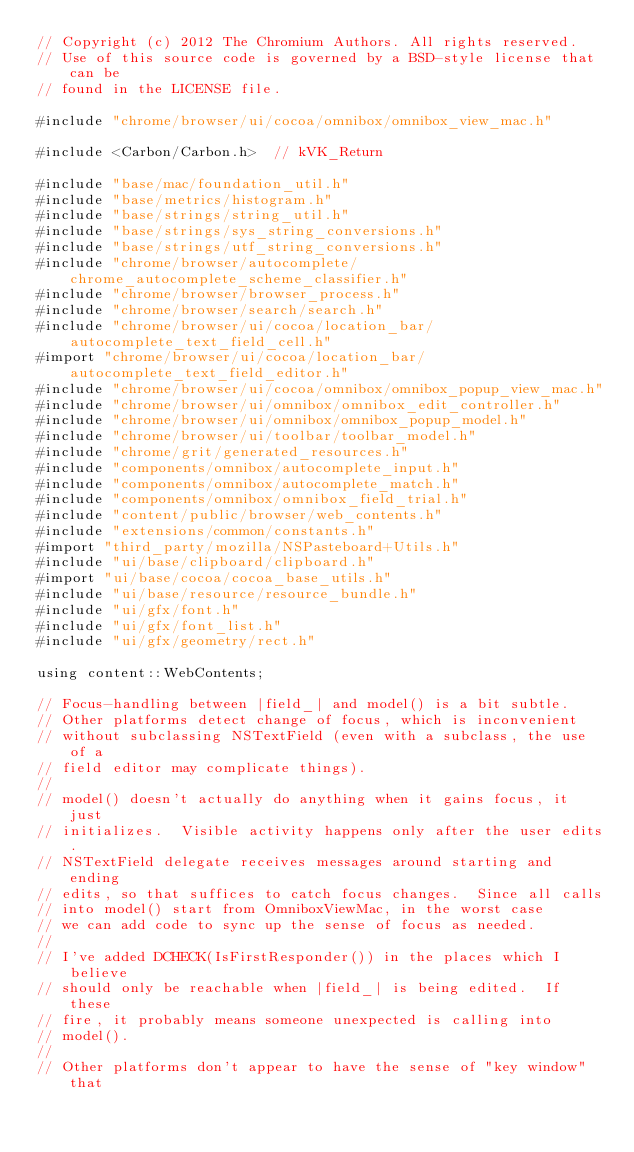<code> <loc_0><loc_0><loc_500><loc_500><_ObjectiveC_>// Copyright (c) 2012 The Chromium Authors. All rights reserved.
// Use of this source code is governed by a BSD-style license that can be
// found in the LICENSE file.

#include "chrome/browser/ui/cocoa/omnibox/omnibox_view_mac.h"

#include <Carbon/Carbon.h>  // kVK_Return

#include "base/mac/foundation_util.h"
#include "base/metrics/histogram.h"
#include "base/strings/string_util.h"
#include "base/strings/sys_string_conversions.h"
#include "base/strings/utf_string_conversions.h"
#include "chrome/browser/autocomplete/chrome_autocomplete_scheme_classifier.h"
#include "chrome/browser/browser_process.h"
#include "chrome/browser/search/search.h"
#include "chrome/browser/ui/cocoa/location_bar/autocomplete_text_field_cell.h"
#import "chrome/browser/ui/cocoa/location_bar/autocomplete_text_field_editor.h"
#include "chrome/browser/ui/cocoa/omnibox/omnibox_popup_view_mac.h"
#include "chrome/browser/ui/omnibox/omnibox_edit_controller.h"
#include "chrome/browser/ui/omnibox/omnibox_popup_model.h"
#include "chrome/browser/ui/toolbar/toolbar_model.h"
#include "chrome/grit/generated_resources.h"
#include "components/omnibox/autocomplete_input.h"
#include "components/omnibox/autocomplete_match.h"
#include "components/omnibox/omnibox_field_trial.h"
#include "content/public/browser/web_contents.h"
#include "extensions/common/constants.h"
#import "third_party/mozilla/NSPasteboard+Utils.h"
#include "ui/base/clipboard/clipboard.h"
#import "ui/base/cocoa/cocoa_base_utils.h"
#include "ui/base/resource/resource_bundle.h"
#include "ui/gfx/font.h"
#include "ui/gfx/font_list.h"
#include "ui/gfx/geometry/rect.h"

using content::WebContents;

// Focus-handling between |field_| and model() is a bit subtle.
// Other platforms detect change of focus, which is inconvenient
// without subclassing NSTextField (even with a subclass, the use of a
// field editor may complicate things).
//
// model() doesn't actually do anything when it gains focus, it just
// initializes.  Visible activity happens only after the user edits.
// NSTextField delegate receives messages around starting and ending
// edits, so that suffices to catch focus changes.  Since all calls
// into model() start from OmniboxViewMac, in the worst case
// we can add code to sync up the sense of focus as needed.
//
// I've added DCHECK(IsFirstResponder()) in the places which I believe
// should only be reachable when |field_| is being edited.  If these
// fire, it probably means someone unexpected is calling into
// model().
//
// Other platforms don't appear to have the sense of "key window" that</code> 